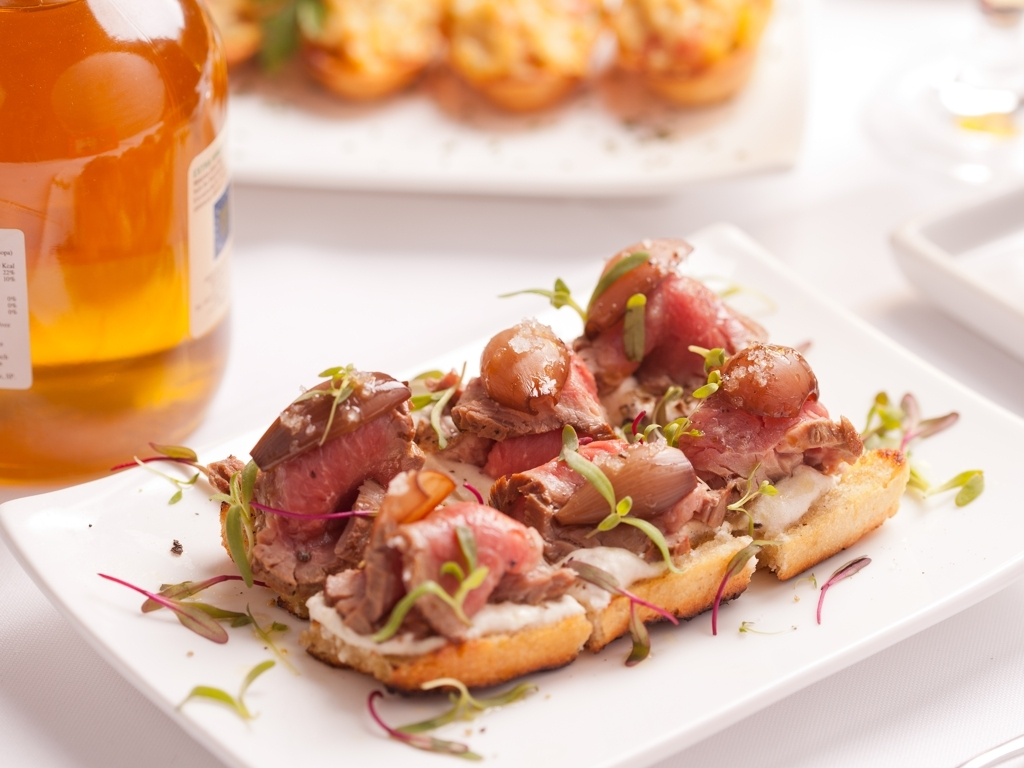What kind of event or setting would this dish be suitable for? This dish, with its elegant presentation and bite-sized portions, seems perfect for a cocktail party or as an appetizer at a formal event. Its sophisticated look suggests it's meant to impress guests and stimulate the palate before a main course. 